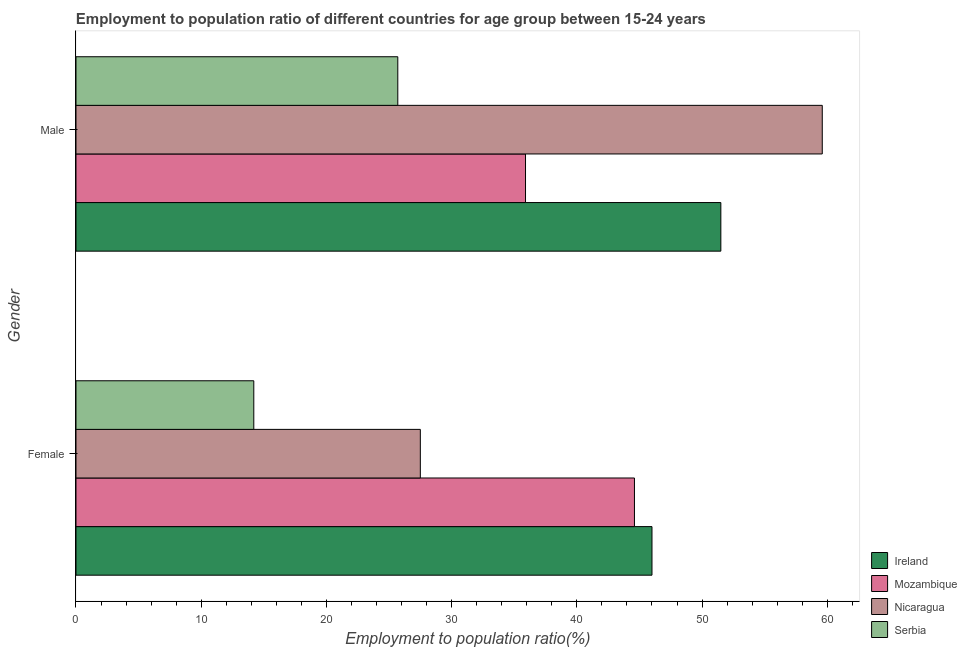Are the number of bars per tick equal to the number of legend labels?
Offer a terse response. Yes. Are the number of bars on each tick of the Y-axis equal?
Give a very brief answer. Yes. How many bars are there on the 2nd tick from the top?
Keep it short and to the point. 4. How many bars are there on the 2nd tick from the bottom?
Your response must be concise. 4. Across all countries, what is the maximum employment to population ratio(male)?
Your response must be concise. 59.6. Across all countries, what is the minimum employment to population ratio(female)?
Provide a succinct answer. 14.2. In which country was the employment to population ratio(female) maximum?
Keep it short and to the point. Ireland. In which country was the employment to population ratio(female) minimum?
Provide a succinct answer. Serbia. What is the total employment to population ratio(female) in the graph?
Your response must be concise. 132.3. What is the difference between the employment to population ratio(male) in Nicaragua and that in Mozambique?
Your answer should be very brief. 23.7. What is the average employment to population ratio(male) per country?
Provide a succinct answer. 43.18. What is the difference between the employment to population ratio(male) and employment to population ratio(female) in Ireland?
Offer a very short reply. 5.5. What is the ratio of the employment to population ratio(female) in Serbia to that in Ireland?
Keep it short and to the point. 0.31. Is the employment to population ratio(female) in Nicaragua less than that in Ireland?
Offer a very short reply. Yes. In how many countries, is the employment to population ratio(female) greater than the average employment to population ratio(female) taken over all countries?
Provide a succinct answer. 2. What does the 2nd bar from the top in Male represents?
Your answer should be compact. Nicaragua. What does the 1st bar from the bottom in Female represents?
Make the answer very short. Ireland. How many bars are there?
Keep it short and to the point. 8. Are all the bars in the graph horizontal?
Provide a succinct answer. Yes. How many countries are there in the graph?
Offer a very short reply. 4. Are the values on the major ticks of X-axis written in scientific E-notation?
Provide a succinct answer. No. Does the graph contain grids?
Give a very brief answer. No. Where does the legend appear in the graph?
Offer a very short reply. Bottom right. How are the legend labels stacked?
Keep it short and to the point. Vertical. What is the title of the graph?
Provide a succinct answer. Employment to population ratio of different countries for age group between 15-24 years. What is the label or title of the X-axis?
Provide a short and direct response. Employment to population ratio(%). What is the Employment to population ratio(%) of Ireland in Female?
Ensure brevity in your answer.  46. What is the Employment to population ratio(%) in Mozambique in Female?
Offer a very short reply. 44.6. What is the Employment to population ratio(%) in Serbia in Female?
Offer a very short reply. 14.2. What is the Employment to population ratio(%) of Ireland in Male?
Provide a succinct answer. 51.5. What is the Employment to population ratio(%) in Mozambique in Male?
Your answer should be very brief. 35.9. What is the Employment to population ratio(%) in Nicaragua in Male?
Your answer should be very brief. 59.6. What is the Employment to population ratio(%) of Serbia in Male?
Offer a very short reply. 25.7. Across all Gender, what is the maximum Employment to population ratio(%) of Ireland?
Give a very brief answer. 51.5. Across all Gender, what is the maximum Employment to population ratio(%) in Mozambique?
Your answer should be very brief. 44.6. Across all Gender, what is the maximum Employment to population ratio(%) of Nicaragua?
Your response must be concise. 59.6. Across all Gender, what is the maximum Employment to population ratio(%) of Serbia?
Ensure brevity in your answer.  25.7. Across all Gender, what is the minimum Employment to population ratio(%) of Ireland?
Your response must be concise. 46. Across all Gender, what is the minimum Employment to population ratio(%) of Mozambique?
Ensure brevity in your answer.  35.9. Across all Gender, what is the minimum Employment to population ratio(%) of Nicaragua?
Provide a succinct answer. 27.5. Across all Gender, what is the minimum Employment to population ratio(%) of Serbia?
Provide a succinct answer. 14.2. What is the total Employment to population ratio(%) of Ireland in the graph?
Provide a succinct answer. 97.5. What is the total Employment to population ratio(%) in Mozambique in the graph?
Make the answer very short. 80.5. What is the total Employment to population ratio(%) in Nicaragua in the graph?
Keep it short and to the point. 87.1. What is the total Employment to population ratio(%) of Serbia in the graph?
Provide a succinct answer. 39.9. What is the difference between the Employment to population ratio(%) in Mozambique in Female and that in Male?
Offer a very short reply. 8.7. What is the difference between the Employment to population ratio(%) of Nicaragua in Female and that in Male?
Your response must be concise. -32.1. What is the difference between the Employment to population ratio(%) of Serbia in Female and that in Male?
Give a very brief answer. -11.5. What is the difference between the Employment to population ratio(%) in Ireland in Female and the Employment to population ratio(%) in Serbia in Male?
Your response must be concise. 20.3. What is the difference between the Employment to population ratio(%) in Mozambique in Female and the Employment to population ratio(%) in Serbia in Male?
Ensure brevity in your answer.  18.9. What is the average Employment to population ratio(%) in Ireland per Gender?
Offer a very short reply. 48.75. What is the average Employment to population ratio(%) of Mozambique per Gender?
Your answer should be compact. 40.25. What is the average Employment to population ratio(%) in Nicaragua per Gender?
Give a very brief answer. 43.55. What is the average Employment to population ratio(%) in Serbia per Gender?
Your answer should be very brief. 19.95. What is the difference between the Employment to population ratio(%) in Ireland and Employment to population ratio(%) in Mozambique in Female?
Make the answer very short. 1.4. What is the difference between the Employment to population ratio(%) in Ireland and Employment to population ratio(%) in Nicaragua in Female?
Keep it short and to the point. 18.5. What is the difference between the Employment to population ratio(%) in Ireland and Employment to population ratio(%) in Serbia in Female?
Make the answer very short. 31.8. What is the difference between the Employment to population ratio(%) in Mozambique and Employment to population ratio(%) in Nicaragua in Female?
Provide a succinct answer. 17.1. What is the difference between the Employment to population ratio(%) in Mozambique and Employment to population ratio(%) in Serbia in Female?
Your response must be concise. 30.4. What is the difference between the Employment to population ratio(%) in Nicaragua and Employment to population ratio(%) in Serbia in Female?
Give a very brief answer. 13.3. What is the difference between the Employment to population ratio(%) of Ireland and Employment to population ratio(%) of Serbia in Male?
Provide a succinct answer. 25.8. What is the difference between the Employment to population ratio(%) in Mozambique and Employment to population ratio(%) in Nicaragua in Male?
Provide a short and direct response. -23.7. What is the difference between the Employment to population ratio(%) of Mozambique and Employment to population ratio(%) of Serbia in Male?
Make the answer very short. 10.2. What is the difference between the Employment to population ratio(%) in Nicaragua and Employment to population ratio(%) in Serbia in Male?
Your answer should be very brief. 33.9. What is the ratio of the Employment to population ratio(%) in Ireland in Female to that in Male?
Keep it short and to the point. 0.89. What is the ratio of the Employment to population ratio(%) of Mozambique in Female to that in Male?
Make the answer very short. 1.24. What is the ratio of the Employment to population ratio(%) of Nicaragua in Female to that in Male?
Your response must be concise. 0.46. What is the ratio of the Employment to population ratio(%) of Serbia in Female to that in Male?
Make the answer very short. 0.55. What is the difference between the highest and the second highest Employment to population ratio(%) of Ireland?
Your answer should be very brief. 5.5. What is the difference between the highest and the second highest Employment to population ratio(%) of Nicaragua?
Provide a short and direct response. 32.1. What is the difference between the highest and the second highest Employment to population ratio(%) of Serbia?
Offer a very short reply. 11.5. What is the difference between the highest and the lowest Employment to population ratio(%) in Nicaragua?
Keep it short and to the point. 32.1. 